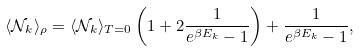Convert formula to latex. <formula><loc_0><loc_0><loc_500><loc_500>\langle { \mathcal { N } } _ { k } \rangle _ { \rho } = \langle { \mathcal { N } } _ { k } \rangle _ { T = 0 } \left ( 1 + 2 \frac { 1 } { e ^ { \beta E _ { k } } - 1 } \right ) + \frac { 1 } { e ^ { \beta E _ { k } } - 1 } ,</formula> 